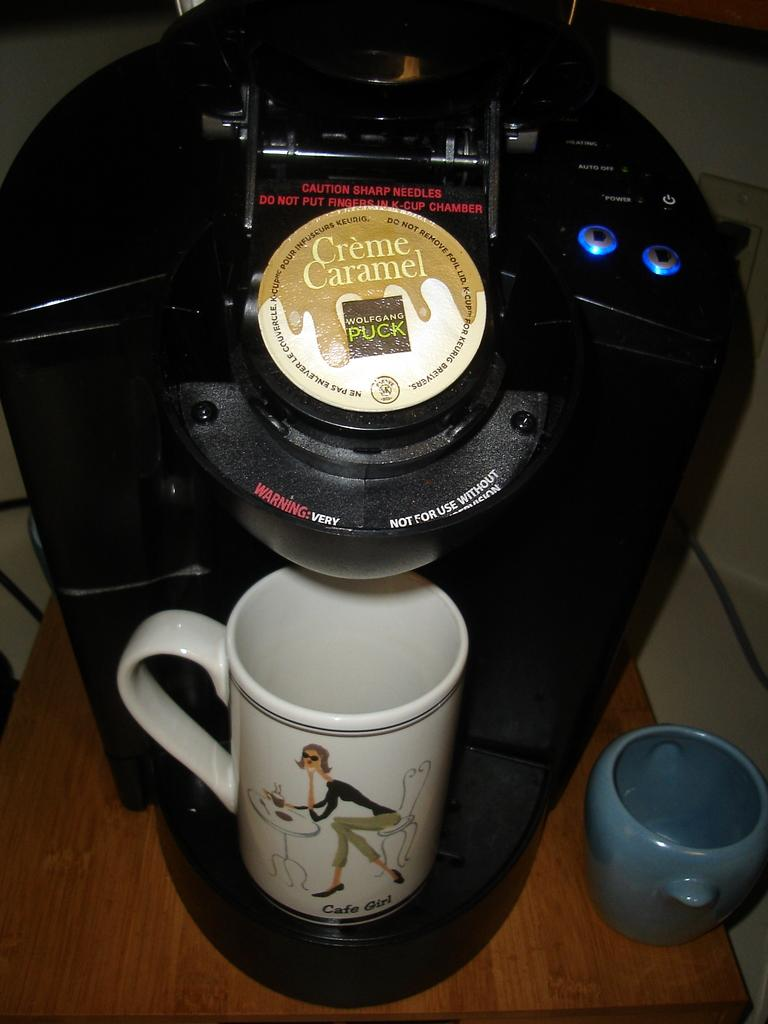Provide a one-sentence caption for the provided image. A coffee maker that has a flavoring of Creme Caramel waiting to boil. 